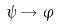<formula> <loc_0><loc_0><loc_500><loc_500>\psi \rightarrow \varphi</formula> 